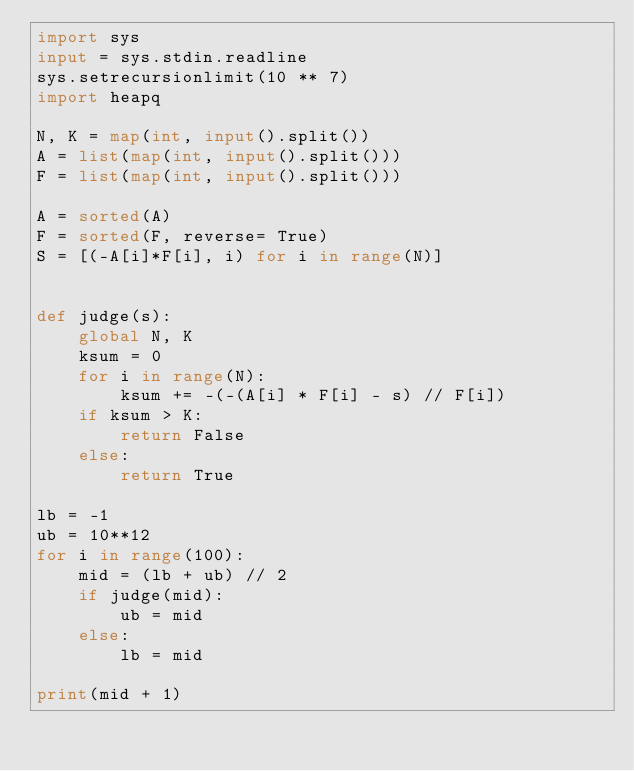Convert code to text. <code><loc_0><loc_0><loc_500><loc_500><_Python_>import sys
input = sys.stdin.readline
sys.setrecursionlimit(10 ** 7)
import heapq

N, K = map(int, input().split())
A = list(map(int, input().split()))
F = list(map(int, input().split()))

A = sorted(A)
F = sorted(F, reverse= True)
S = [(-A[i]*F[i], i) for i in range(N)]


def judge(s):
    global N, K
    ksum = 0
    for i in range(N):
        ksum += -(-(A[i] * F[i] - s) // F[i])
    if ksum > K:
        return False
    else:
        return True

lb = -1
ub = 10**12 
for i in range(100):
    mid = (lb + ub) // 2
    if judge(mid):
        ub = mid
    else:
        lb = mid

print(mid + 1)
</code> 